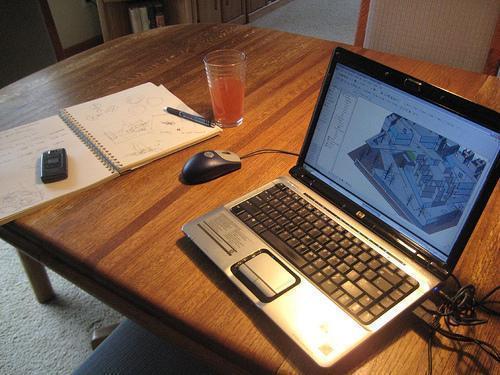What is the computer most at risk of?
Make your selection and explain in format: 'Answer: answer
Rationale: rationale.'
Options: Flood hazard, hail hazard, fire hazard, lightning hazard. Answer: fire hazard.
Rationale: The computer is most at risk of fire because of all of the wires. 